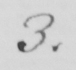Can you tell me what this handwritten text says? 3 . 